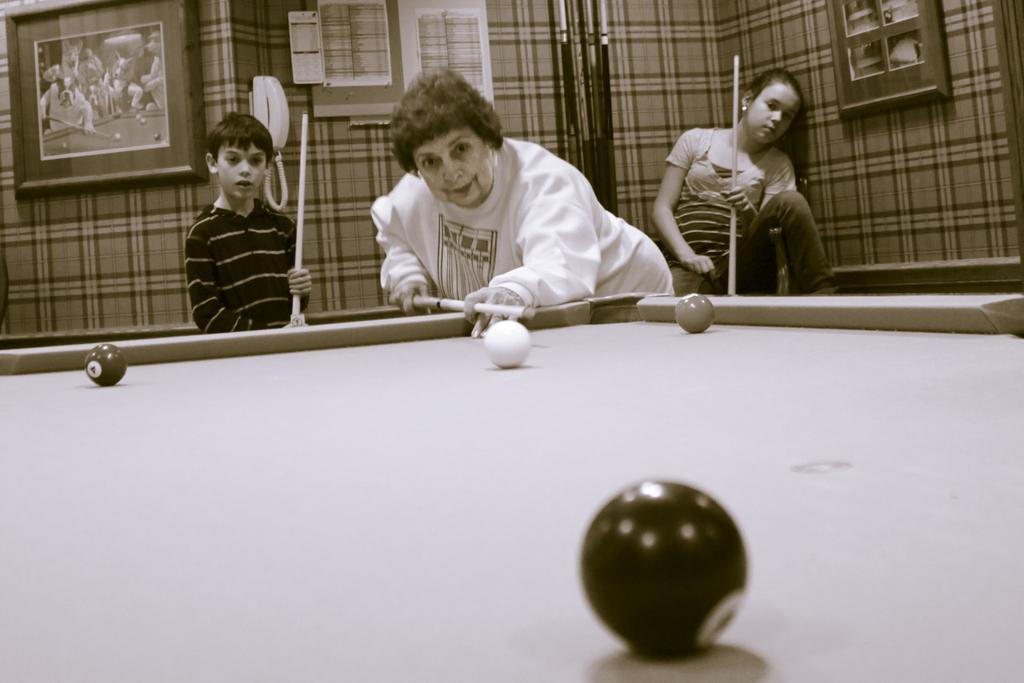How would you summarize this image in a sentence or two? In this picture we can see three people holding sticks in their hands. There are balls on the tennis table. We can see a few frames, telephone and some papers in the background. 